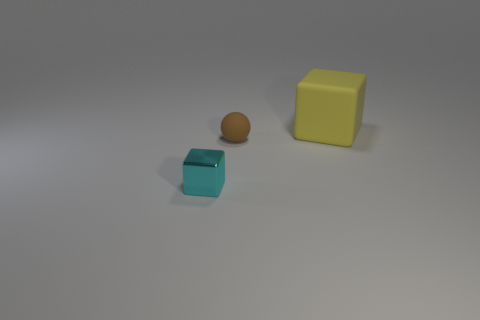Add 1 tiny cyan shiny things. How many objects exist? 4 Subtract all balls. How many objects are left? 2 Add 3 cyan metallic objects. How many cyan metallic objects exist? 4 Subtract 0 brown cylinders. How many objects are left? 3 Subtract all brown things. Subtract all red metal objects. How many objects are left? 2 Add 3 matte spheres. How many matte spheres are left? 4 